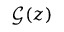Convert formula to latex. <formula><loc_0><loc_0><loc_500><loc_500>\mathcal { G } ( z )</formula> 